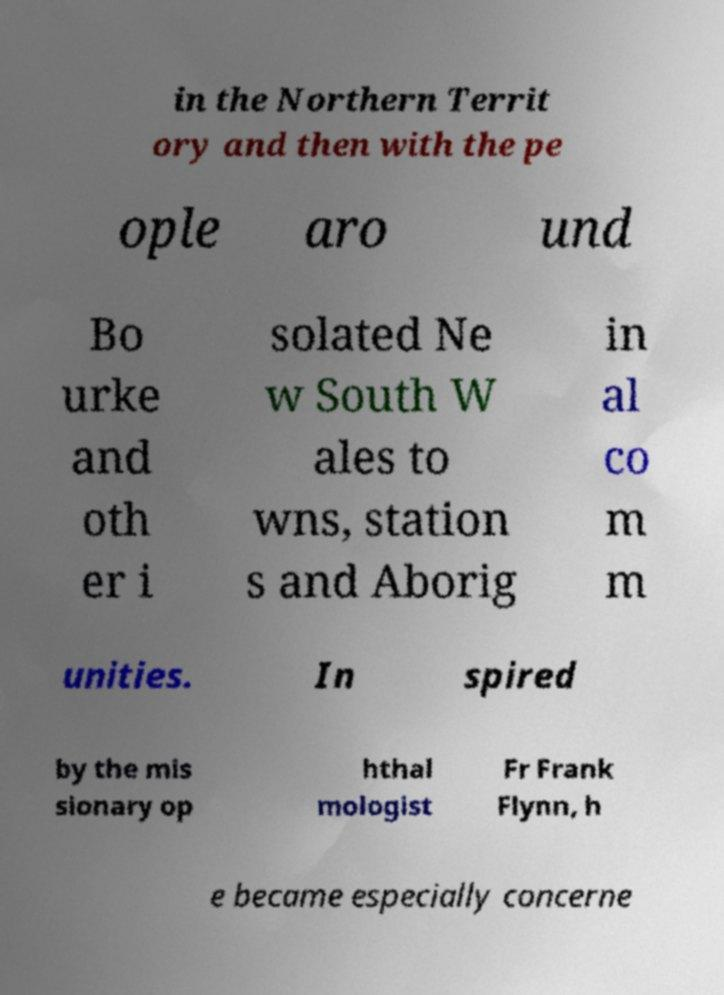Please read and relay the text visible in this image. What does it say? in the Northern Territ ory and then with the pe ople aro und Bo urke and oth er i solated Ne w South W ales to wns, station s and Aborig in al co m m unities. In spired by the mis sionary op hthal mologist Fr Frank Flynn, h e became especially concerne 